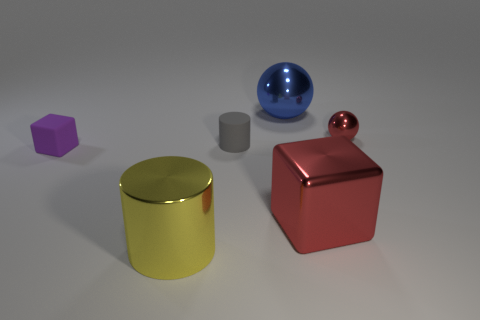What number of objects are both behind the tiny red sphere and on the left side of the yellow thing?
Keep it short and to the point. 0. How many large yellow shiny objects have the same shape as the big blue metallic object?
Give a very brief answer. 0. Are the red ball and the small purple cube made of the same material?
Provide a short and direct response. No. There is a rubber object right of the large thing on the left side of the gray matte cylinder; what is its shape?
Provide a short and direct response. Cylinder. How many small gray matte things are behind the red thing that is in front of the purple rubber thing?
Give a very brief answer. 1. The large thing that is left of the large red metallic cube and in front of the purple cube is made of what material?
Give a very brief answer. Metal. What shape is the red metallic object that is the same size as the gray object?
Provide a short and direct response. Sphere. What color is the cylinder in front of the red object to the left of the metal object that is on the right side of the red shiny block?
Your answer should be very brief. Yellow. How many things are either tiny objects that are on the left side of the big metallic cube or small matte things?
Provide a short and direct response. 2. There is a yellow object that is the same size as the red block; what is its material?
Offer a terse response. Metal. 